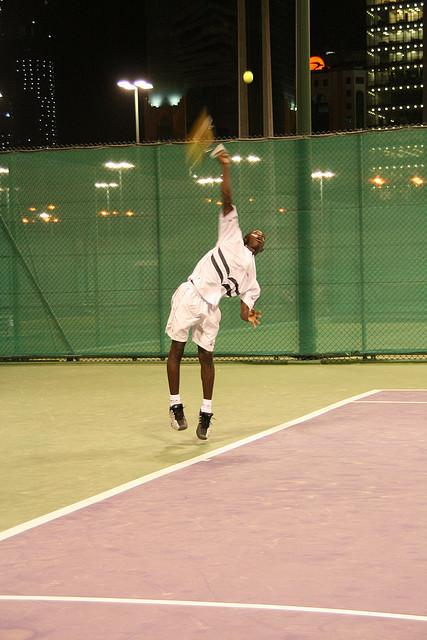What is the man swinging?

Choices:
A) baseball bat
B) tennis racquet
C) oar
D) stuffed animal tennis racquet 